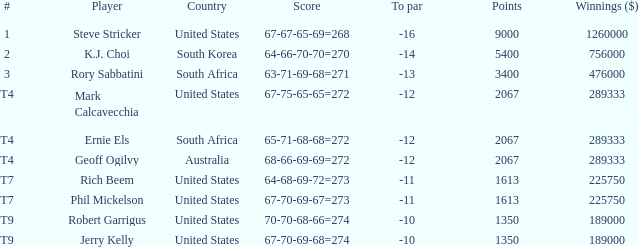Name the number of points for south korea 1.0. 